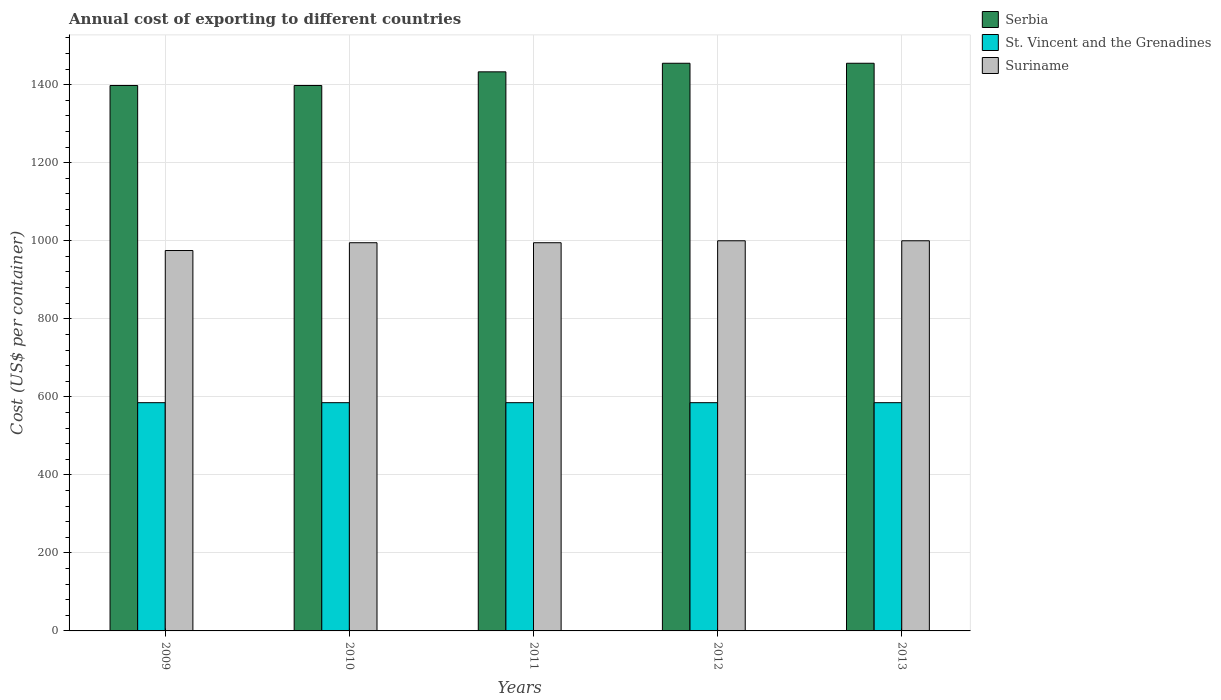What is the total annual cost of exporting in St. Vincent and the Grenadines in 2012?
Provide a succinct answer. 585. Across all years, what is the maximum total annual cost of exporting in Serbia?
Provide a succinct answer. 1455. Across all years, what is the minimum total annual cost of exporting in Suriname?
Make the answer very short. 975. What is the total total annual cost of exporting in St. Vincent and the Grenadines in the graph?
Your response must be concise. 2925. What is the difference between the total annual cost of exporting in Suriname in 2010 and that in 2012?
Ensure brevity in your answer.  -5. What is the difference between the total annual cost of exporting in St. Vincent and the Grenadines in 2010 and the total annual cost of exporting in Serbia in 2013?
Offer a terse response. -870. What is the average total annual cost of exporting in Serbia per year?
Your answer should be compact. 1427.8. In the year 2010, what is the difference between the total annual cost of exporting in St. Vincent and the Grenadines and total annual cost of exporting in Suriname?
Ensure brevity in your answer.  -410. Is the difference between the total annual cost of exporting in St. Vincent and the Grenadines in 2010 and 2011 greater than the difference between the total annual cost of exporting in Suriname in 2010 and 2011?
Ensure brevity in your answer.  No. What is the difference between the highest and the second highest total annual cost of exporting in St. Vincent and the Grenadines?
Provide a succinct answer. 0. What is the difference between the highest and the lowest total annual cost of exporting in Suriname?
Ensure brevity in your answer.  25. Is the sum of the total annual cost of exporting in Serbia in 2009 and 2012 greater than the maximum total annual cost of exporting in St. Vincent and the Grenadines across all years?
Offer a terse response. Yes. What does the 3rd bar from the left in 2012 represents?
Your response must be concise. Suriname. What does the 2nd bar from the right in 2012 represents?
Your response must be concise. St. Vincent and the Grenadines. How many years are there in the graph?
Provide a short and direct response. 5. What is the difference between two consecutive major ticks on the Y-axis?
Provide a short and direct response. 200. Does the graph contain any zero values?
Make the answer very short. No. How many legend labels are there?
Ensure brevity in your answer.  3. What is the title of the graph?
Offer a very short reply. Annual cost of exporting to different countries. Does "Lao PDR" appear as one of the legend labels in the graph?
Offer a very short reply. No. What is the label or title of the X-axis?
Provide a short and direct response. Years. What is the label or title of the Y-axis?
Provide a succinct answer. Cost (US$ per container). What is the Cost (US$ per container) of Serbia in 2009?
Give a very brief answer. 1398. What is the Cost (US$ per container) of St. Vincent and the Grenadines in 2009?
Your answer should be very brief. 585. What is the Cost (US$ per container) of Suriname in 2009?
Make the answer very short. 975. What is the Cost (US$ per container) in Serbia in 2010?
Provide a short and direct response. 1398. What is the Cost (US$ per container) of St. Vincent and the Grenadines in 2010?
Your answer should be compact. 585. What is the Cost (US$ per container) of Suriname in 2010?
Provide a succinct answer. 995. What is the Cost (US$ per container) in Serbia in 2011?
Your response must be concise. 1433. What is the Cost (US$ per container) in St. Vincent and the Grenadines in 2011?
Ensure brevity in your answer.  585. What is the Cost (US$ per container) of Suriname in 2011?
Ensure brevity in your answer.  995. What is the Cost (US$ per container) of Serbia in 2012?
Keep it short and to the point. 1455. What is the Cost (US$ per container) in St. Vincent and the Grenadines in 2012?
Your answer should be compact. 585. What is the Cost (US$ per container) of Serbia in 2013?
Make the answer very short. 1455. What is the Cost (US$ per container) of St. Vincent and the Grenadines in 2013?
Ensure brevity in your answer.  585. What is the Cost (US$ per container) of Suriname in 2013?
Make the answer very short. 1000. Across all years, what is the maximum Cost (US$ per container) in Serbia?
Your response must be concise. 1455. Across all years, what is the maximum Cost (US$ per container) of St. Vincent and the Grenadines?
Your answer should be very brief. 585. Across all years, what is the maximum Cost (US$ per container) in Suriname?
Keep it short and to the point. 1000. Across all years, what is the minimum Cost (US$ per container) in Serbia?
Give a very brief answer. 1398. Across all years, what is the minimum Cost (US$ per container) of St. Vincent and the Grenadines?
Offer a terse response. 585. Across all years, what is the minimum Cost (US$ per container) of Suriname?
Your answer should be compact. 975. What is the total Cost (US$ per container) in Serbia in the graph?
Provide a short and direct response. 7139. What is the total Cost (US$ per container) in St. Vincent and the Grenadines in the graph?
Your response must be concise. 2925. What is the total Cost (US$ per container) of Suriname in the graph?
Give a very brief answer. 4965. What is the difference between the Cost (US$ per container) in Serbia in 2009 and that in 2010?
Offer a terse response. 0. What is the difference between the Cost (US$ per container) in St. Vincent and the Grenadines in 2009 and that in 2010?
Your response must be concise. 0. What is the difference between the Cost (US$ per container) of Suriname in 2009 and that in 2010?
Give a very brief answer. -20. What is the difference between the Cost (US$ per container) in Serbia in 2009 and that in 2011?
Offer a terse response. -35. What is the difference between the Cost (US$ per container) of St. Vincent and the Grenadines in 2009 and that in 2011?
Offer a terse response. 0. What is the difference between the Cost (US$ per container) of Serbia in 2009 and that in 2012?
Your response must be concise. -57. What is the difference between the Cost (US$ per container) of Suriname in 2009 and that in 2012?
Make the answer very short. -25. What is the difference between the Cost (US$ per container) of Serbia in 2009 and that in 2013?
Make the answer very short. -57. What is the difference between the Cost (US$ per container) in Serbia in 2010 and that in 2011?
Your response must be concise. -35. What is the difference between the Cost (US$ per container) of St. Vincent and the Grenadines in 2010 and that in 2011?
Ensure brevity in your answer.  0. What is the difference between the Cost (US$ per container) of Serbia in 2010 and that in 2012?
Provide a short and direct response. -57. What is the difference between the Cost (US$ per container) of Suriname in 2010 and that in 2012?
Your response must be concise. -5. What is the difference between the Cost (US$ per container) of Serbia in 2010 and that in 2013?
Make the answer very short. -57. What is the difference between the Cost (US$ per container) of Suriname in 2010 and that in 2013?
Make the answer very short. -5. What is the difference between the Cost (US$ per container) of St. Vincent and the Grenadines in 2011 and that in 2012?
Offer a very short reply. 0. What is the difference between the Cost (US$ per container) in Suriname in 2011 and that in 2012?
Provide a succinct answer. -5. What is the difference between the Cost (US$ per container) in Serbia in 2011 and that in 2013?
Provide a succinct answer. -22. What is the difference between the Cost (US$ per container) of St. Vincent and the Grenadines in 2011 and that in 2013?
Ensure brevity in your answer.  0. What is the difference between the Cost (US$ per container) of Suriname in 2011 and that in 2013?
Your response must be concise. -5. What is the difference between the Cost (US$ per container) in St. Vincent and the Grenadines in 2012 and that in 2013?
Provide a short and direct response. 0. What is the difference between the Cost (US$ per container) of Suriname in 2012 and that in 2013?
Give a very brief answer. 0. What is the difference between the Cost (US$ per container) in Serbia in 2009 and the Cost (US$ per container) in St. Vincent and the Grenadines in 2010?
Your answer should be compact. 813. What is the difference between the Cost (US$ per container) in Serbia in 2009 and the Cost (US$ per container) in Suriname in 2010?
Your answer should be compact. 403. What is the difference between the Cost (US$ per container) of St. Vincent and the Grenadines in 2009 and the Cost (US$ per container) of Suriname in 2010?
Keep it short and to the point. -410. What is the difference between the Cost (US$ per container) of Serbia in 2009 and the Cost (US$ per container) of St. Vincent and the Grenadines in 2011?
Give a very brief answer. 813. What is the difference between the Cost (US$ per container) of Serbia in 2009 and the Cost (US$ per container) of Suriname in 2011?
Your answer should be compact. 403. What is the difference between the Cost (US$ per container) of St. Vincent and the Grenadines in 2009 and the Cost (US$ per container) of Suriname in 2011?
Offer a very short reply. -410. What is the difference between the Cost (US$ per container) in Serbia in 2009 and the Cost (US$ per container) in St. Vincent and the Grenadines in 2012?
Provide a succinct answer. 813. What is the difference between the Cost (US$ per container) in Serbia in 2009 and the Cost (US$ per container) in Suriname in 2012?
Ensure brevity in your answer.  398. What is the difference between the Cost (US$ per container) in St. Vincent and the Grenadines in 2009 and the Cost (US$ per container) in Suriname in 2012?
Keep it short and to the point. -415. What is the difference between the Cost (US$ per container) in Serbia in 2009 and the Cost (US$ per container) in St. Vincent and the Grenadines in 2013?
Offer a terse response. 813. What is the difference between the Cost (US$ per container) of Serbia in 2009 and the Cost (US$ per container) of Suriname in 2013?
Ensure brevity in your answer.  398. What is the difference between the Cost (US$ per container) in St. Vincent and the Grenadines in 2009 and the Cost (US$ per container) in Suriname in 2013?
Your answer should be compact. -415. What is the difference between the Cost (US$ per container) of Serbia in 2010 and the Cost (US$ per container) of St. Vincent and the Grenadines in 2011?
Your answer should be very brief. 813. What is the difference between the Cost (US$ per container) of Serbia in 2010 and the Cost (US$ per container) of Suriname in 2011?
Your answer should be very brief. 403. What is the difference between the Cost (US$ per container) in St. Vincent and the Grenadines in 2010 and the Cost (US$ per container) in Suriname in 2011?
Offer a very short reply. -410. What is the difference between the Cost (US$ per container) in Serbia in 2010 and the Cost (US$ per container) in St. Vincent and the Grenadines in 2012?
Make the answer very short. 813. What is the difference between the Cost (US$ per container) in Serbia in 2010 and the Cost (US$ per container) in Suriname in 2012?
Provide a succinct answer. 398. What is the difference between the Cost (US$ per container) of St. Vincent and the Grenadines in 2010 and the Cost (US$ per container) of Suriname in 2012?
Offer a terse response. -415. What is the difference between the Cost (US$ per container) in Serbia in 2010 and the Cost (US$ per container) in St. Vincent and the Grenadines in 2013?
Your response must be concise. 813. What is the difference between the Cost (US$ per container) of Serbia in 2010 and the Cost (US$ per container) of Suriname in 2013?
Give a very brief answer. 398. What is the difference between the Cost (US$ per container) of St. Vincent and the Grenadines in 2010 and the Cost (US$ per container) of Suriname in 2013?
Your answer should be compact. -415. What is the difference between the Cost (US$ per container) of Serbia in 2011 and the Cost (US$ per container) of St. Vincent and the Grenadines in 2012?
Offer a terse response. 848. What is the difference between the Cost (US$ per container) of Serbia in 2011 and the Cost (US$ per container) of Suriname in 2012?
Offer a terse response. 433. What is the difference between the Cost (US$ per container) of St. Vincent and the Grenadines in 2011 and the Cost (US$ per container) of Suriname in 2012?
Your answer should be compact. -415. What is the difference between the Cost (US$ per container) in Serbia in 2011 and the Cost (US$ per container) in St. Vincent and the Grenadines in 2013?
Keep it short and to the point. 848. What is the difference between the Cost (US$ per container) of Serbia in 2011 and the Cost (US$ per container) of Suriname in 2013?
Offer a very short reply. 433. What is the difference between the Cost (US$ per container) in St. Vincent and the Grenadines in 2011 and the Cost (US$ per container) in Suriname in 2013?
Provide a succinct answer. -415. What is the difference between the Cost (US$ per container) of Serbia in 2012 and the Cost (US$ per container) of St. Vincent and the Grenadines in 2013?
Your response must be concise. 870. What is the difference between the Cost (US$ per container) in Serbia in 2012 and the Cost (US$ per container) in Suriname in 2013?
Make the answer very short. 455. What is the difference between the Cost (US$ per container) in St. Vincent and the Grenadines in 2012 and the Cost (US$ per container) in Suriname in 2013?
Give a very brief answer. -415. What is the average Cost (US$ per container) of Serbia per year?
Your answer should be very brief. 1427.8. What is the average Cost (US$ per container) of St. Vincent and the Grenadines per year?
Your response must be concise. 585. What is the average Cost (US$ per container) of Suriname per year?
Provide a short and direct response. 993. In the year 2009, what is the difference between the Cost (US$ per container) in Serbia and Cost (US$ per container) in St. Vincent and the Grenadines?
Your answer should be very brief. 813. In the year 2009, what is the difference between the Cost (US$ per container) of Serbia and Cost (US$ per container) of Suriname?
Provide a short and direct response. 423. In the year 2009, what is the difference between the Cost (US$ per container) of St. Vincent and the Grenadines and Cost (US$ per container) of Suriname?
Your response must be concise. -390. In the year 2010, what is the difference between the Cost (US$ per container) in Serbia and Cost (US$ per container) in St. Vincent and the Grenadines?
Keep it short and to the point. 813. In the year 2010, what is the difference between the Cost (US$ per container) of Serbia and Cost (US$ per container) of Suriname?
Give a very brief answer. 403. In the year 2010, what is the difference between the Cost (US$ per container) in St. Vincent and the Grenadines and Cost (US$ per container) in Suriname?
Your answer should be compact. -410. In the year 2011, what is the difference between the Cost (US$ per container) of Serbia and Cost (US$ per container) of St. Vincent and the Grenadines?
Make the answer very short. 848. In the year 2011, what is the difference between the Cost (US$ per container) of Serbia and Cost (US$ per container) of Suriname?
Offer a terse response. 438. In the year 2011, what is the difference between the Cost (US$ per container) in St. Vincent and the Grenadines and Cost (US$ per container) in Suriname?
Offer a terse response. -410. In the year 2012, what is the difference between the Cost (US$ per container) in Serbia and Cost (US$ per container) in St. Vincent and the Grenadines?
Your response must be concise. 870. In the year 2012, what is the difference between the Cost (US$ per container) of Serbia and Cost (US$ per container) of Suriname?
Your response must be concise. 455. In the year 2012, what is the difference between the Cost (US$ per container) in St. Vincent and the Grenadines and Cost (US$ per container) in Suriname?
Your answer should be very brief. -415. In the year 2013, what is the difference between the Cost (US$ per container) of Serbia and Cost (US$ per container) of St. Vincent and the Grenadines?
Your answer should be very brief. 870. In the year 2013, what is the difference between the Cost (US$ per container) of Serbia and Cost (US$ per container) of Suriname?
Your response must be concise. 455. In the year 2013, what is the difference between the Cost (US$ per container) of St. Vincent and the Grenadines and Cost (US$ per container) of Suriname?
Make the answer very short. -415. What is the ratio of the Cost (US$ per container) in Serbia in 2009 to that in 2010?
Your answer should be compact. 1. What is the ratio of the Cost (US$ per container) in Suriname in 2009 to that in 2010?
Ensure brevity in your answer.  0.98. What is the ratio of the Cost (US$ per container) of Serbia in 2009 to that in 2011?
Give a very brief answer. 0.98. What is the ratio of the Cost (US$ per container) in St. Vincent and the Grenadines in 2009 to that in 2011?
Offer a very short reply. 1. What is the ratio of the Cost (US$ per container) of Suriname in 2009 to that in 2011?
Provide a short and direct response. 0.98. What is the ratio of the Cost (US$ per container) in Serbia in 2009 to that in 2012?
Offer a terse response. 0.96. What is the ratio of the Cost (US$ per container) in Suriname in 2009 to that in 2012?
Ensure brevity in your answer.  0.97. What is the ratio of the Cost (US$ per container) in Serbia in 2009 to that in 2013?
Your answer should be compact. 0.96. What is the ratio of the Cost (US$ per container) of St. Vincent and the Grenadines in 2009 to that in 2013?
Your response must be concise. 1. What is the ratio of the Cost (US$ per container) in Serbia in 2010 to that in 2011?
Your answer should be very brief. 0.98. What is the ratio of the Cost (US$ per container) of St. Vincent and the Grenadines in 2010 to that in 2011?
Provide a short and direct response. 1. What is the ratio of the Cost (US$ per container) in Serbia in 2010 to that in 2012?
Make the answer very short. 0.96. What is the ratio of the Cost (US$ per container) of Suriname in 2010 to that in 2012?
Offer a terse response. 0.99. What is the ratio of the Cost (US$ per container) in Serbia in 2010 to that in 2013?
Provide a short and direct response. 0.96. What is the ratio of the Cost (US$ per container) of Serbia in 2011 to that in 2012?
Give a very brief answer. 0.98. What is the ratio of the Cost (US$ per container) of St. Vincent and the Grenadines in 2011 to that in 2012?
Keep it short and to the point. 1. What is the ratio of the Cost (US$ per container) of Suriname in 2011 to that in 2012?
Give a very brief answer. 0.99. What is the ratio of the Cost (US$ per container) of Serbia in 2011 to that in 2013?
Provide a succinct answer. 0.98. What is the ratio of the Cost (US$ per container) of St. Vincent and the Grenadines in 2011 to that in 2013?
Give a very brief answer. 1. What is the ratio of the Cost (US$ per container) in Suriname in 2011 to that in 2013?
Your answer should be very brief. 0.99. What is the ratio of the Cost (US$ per container) in Serbia in 2012 to that in 2013?
Your answer should be compact. 1. What is the ratio of the Cost (US$ per container) in St. Vincent and the Grenadines in 2012 to that in 2013?
Your answer should be compact. 1. What is the difference between the highest and the second highest Cost (US$ per container) in St. Vincent and the Grenadines?
Your answer should be compact. 0. What is the difference between the highest and the lowest Cost (US$ per container) of St. Vincent and the Grenadines?
Your response must be concise. 0. What is the difference between the highest and the lowest Cost (US$ per container) in Suriname?
Give a very brief answer. 25. 